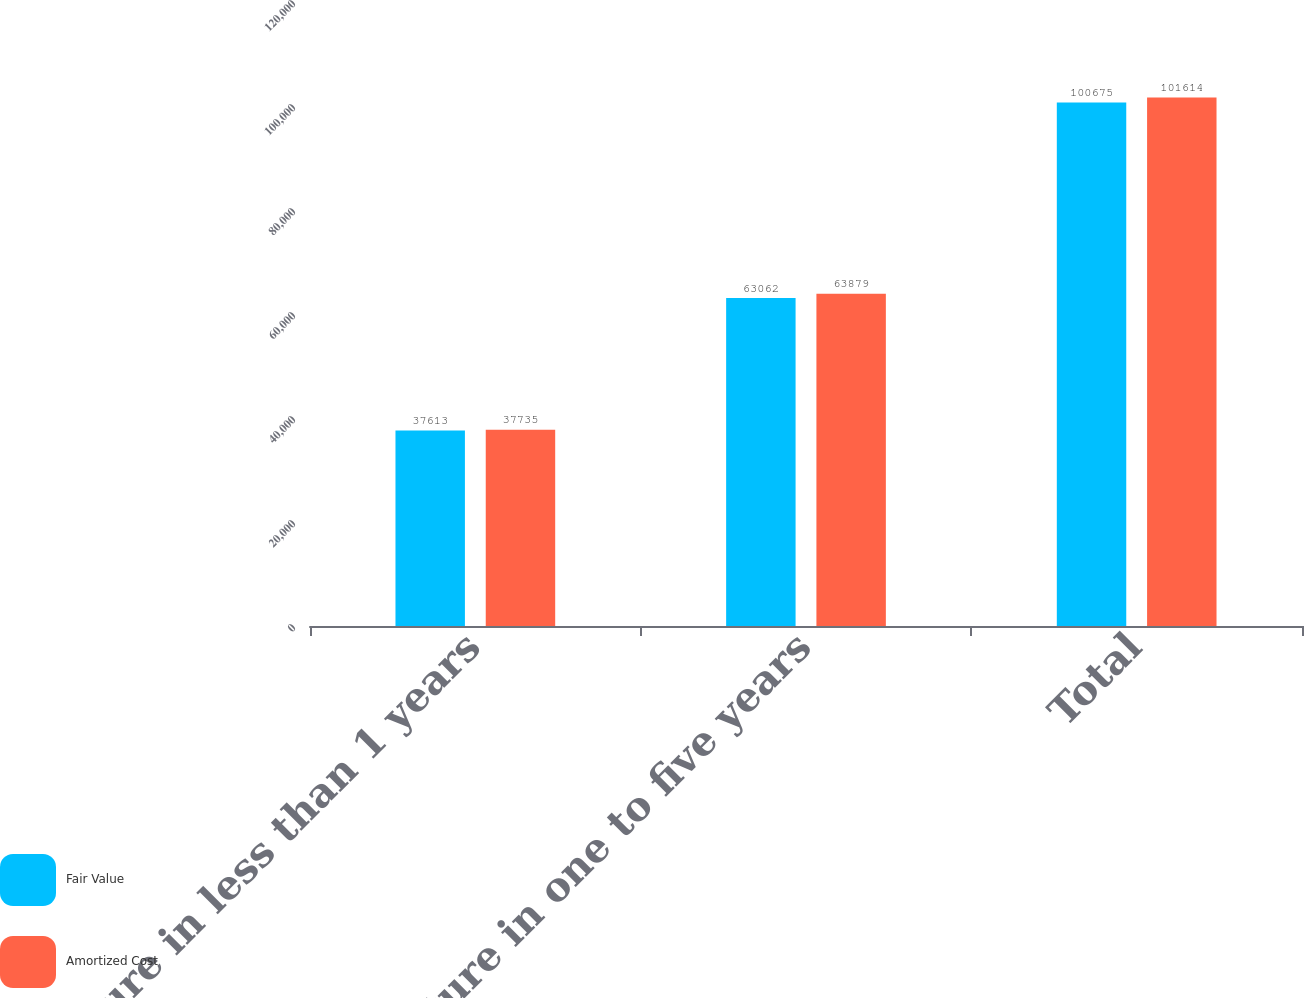Convert chart to OTSL. <chart><loc_0><loc_0><loc_500><loc_500><stacked_bar_chart><ecel><fcel>Mature in less than 1 years<fcel>Mature in one to five years<fcel>Total<nl><fcel>Fair Value<fcel>37613<fcel>63062<fcel>100675<nl><fcel>Amortized Cost<fcel>37735<fcel>63879<fcel>101614<nl></chart> 